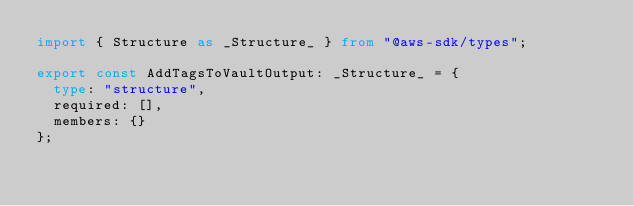Convert code to text. <code><loc_0><loc_0><loc_500><loc_500><_TypeScript_>import { Structure as _Structure_ } from "@aws-sdk/types";

export const AddTagsToVaultOutput: _Structure_ = {
  type: "structure",
  required: [],
  members: {}
};
</code> 